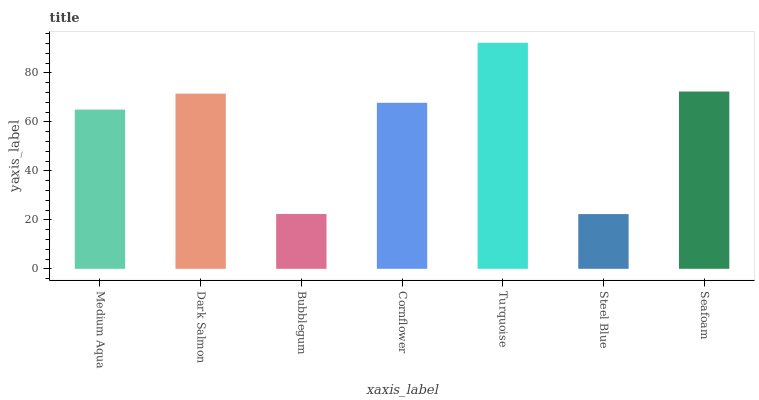Is Dark Salmon the minimum?
Answer yes or no. No. Is Dark Salmon the maximum?
Answer yes or no. No. Is Dark Salmon greater than Medium Aqua?
Answer yes or no. Yes. Is Medium Aqua less than Dark Salmon?
Answer yes or no. Yes. Is Medium Aqua greater than Dark Salmon?
Answer yes or no. No. Is Dark Salmon less than Medium Aqua?
Answer yes or no. No. Is Cornflower the high median?
Answer yes or no. Yes. Is Cornflower the low median?
Answer yes or no. Yes. Is Medium Aqua the high median?
Answer yes or no. No. Is Turquoise the low median?
Answer yes or no. No. 